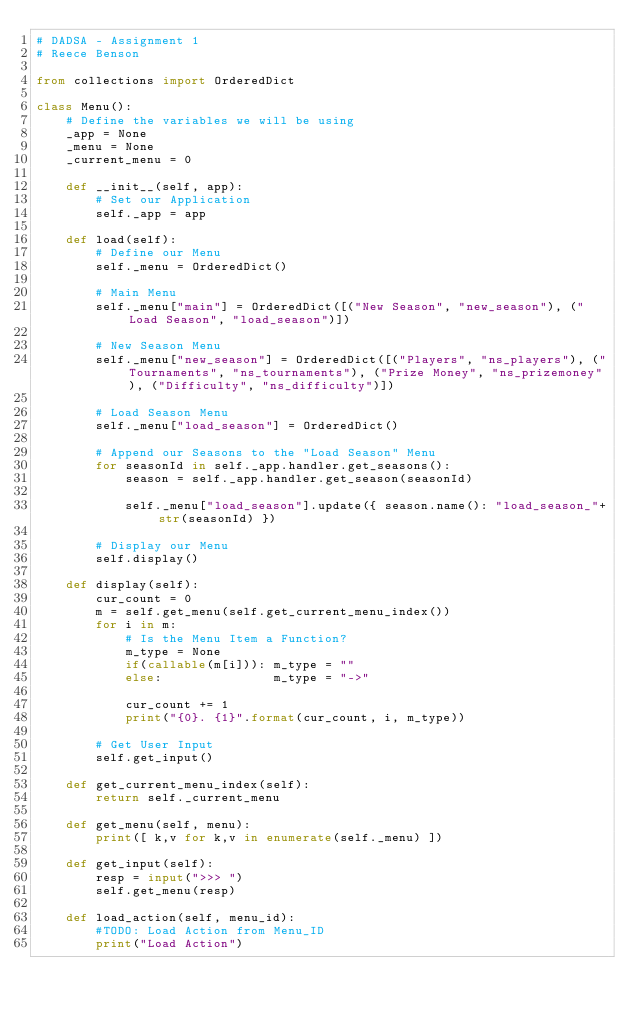Convert code to text. <code><loc_0><loc_0><loc_500><loc_500><_Python_># DADSA - Assignment 1
# Reece Benson

from collections import OrderedDict

class Menu():
    # Define the variables we will be using
    _app = None
    _menu = None
    _current_menu = 0

    def __init__(self, app):
        # Set our Application
        self._app = app

    def load(self):
        # Define our Menu
        self._menu = OrderedDict()

        # Main Menu
        self._menu["main"] = OrderedDict([("New Season", "new_season"), ("Load Season", "load_season")])

        # New Season Menu
        self._menu["new_season"] = OrderedDict([("Players", "ns_players"), ("Tournaments", "ns_tournaments"), ("Prize Money", "ns_prizemoney"), ("Difficulty", "ns_difficulty")])

        # Load Season Menu
        self._menu["load_season"] = OrderedDict()

        # Append our Seasons to the "Load Season" Menu
        for seasonId in self._app.handler.get_seasons():
            season = self._app.handler.get_season(seasonId)

            self._menu["load_season"].update({ season.name(): "load_season_"+str(seasonId) })

        # Display our Menu
        self.display()

    def display(self):
        cur_count = 0
        m = self.get_menu(self.get_current_menu_index())
        for i in m:
            # Is the Menu Item a Function?
            m_type = None
            if(callable(m[i])): m_type = ""
            else:               m_type = "->"
            
            cur_count += 1
            print("{0}. {1}".format(cur_count, i, m_type))

        # Get User Input
        self.get_input()

    def get_current_menu_index(self):
        return self._current_menu

    def get_menu(self, menu):
        print([ k,v for k,v in enumerate(self._menu) ])

    def get_input(self):
        resp = input(">>> ")
        self.get_menu(resp)

    def load_action(self, menu_id):
        #TODO: Load Action from Menu_ID
        print("Load Action")</code> 